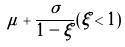Convert formula to latex. <formula><loc_0><loc_0><loc_500><loc_500>\mu + \frac { \sigma } { 1 - \xi } ( \xi < 1 )</formula> 